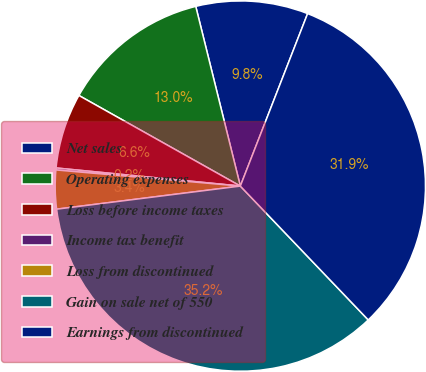<chart> <loc_0><loc_0><loc_500><loc_500><pie_chart><fcel>Net sales<fcel>Operating expenses<fcel>Loss before income taxes<fcel>Income tax benefit<fcel>Loss from discontinued<fcel>Gain on sale net of 550<fcel>Earnings from discontinued<nl><fcel>9.79%<fcel>12.99%<fcel>6.58%<fcel>0.17%<fcel>3.38%<fcel>35.15%<fcel>31.94%<nl></chart> 